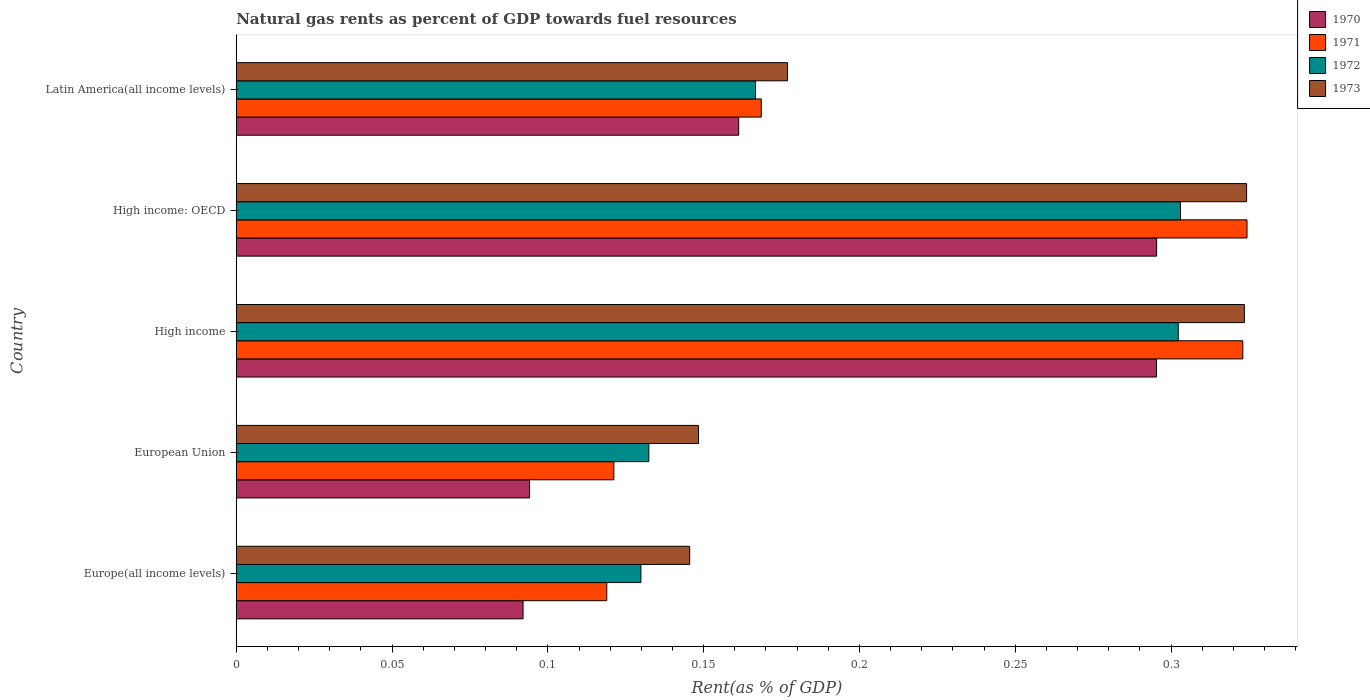How many groups of bars are there?
Offer a very short reply. 5. Are the number of bars per tick equal to the number of legend labels?
Give a very brief answer. Yes. How many bars are there on the 2nd tick from the bottom?
Give a very brief answer. 4. What is the matural gas rent in 1971 in High income: OECD?
Provide a succinct answer. 0.32. Across all countries, what is the maximum matural gas rent in 1973?
Give a very brief answer. 0.32. Across all countries, what is the minimum matural gas rent in 1970?
Your answer should be very brief. 0.09. In which country was the matural gas rent in 1973 maximum?
Provide a succinct answer. High income: OECD. In which country was the matural gas rent in 1970 minimum?
Offer a very short reply. Europe(all income levels). What is the total matural gas rent in 1970 in the graph?
Provide a succinct answer. 0.94. What is the difference between the matural gas rent in 1973 in High income and that in High income: OECD?
Provide a short and direct response. -0. What is the difference between the matural gas rent in 1970 in High income and the matural gas rent in 1973 in High income: OECD?
Ensure brevity in your answer.  -0.03. What is the average matural gas rent in 1970 per country?
Your response must be concise. 0.19. What is the difference between the matural gas rent in 1971 and matural gas rent in 1972 in Europe(all income levels)?
Offer a very short reply. -0.01. In how many countries, is the matural gas rent in 1973 greater than 0.02 %?
Your response must be concise. 5. What is the ratio of the matural gas rent in 1973 in Europe(all income levels) to that in European Union?
Your answer should be very brief. 0.98. Is the matural gas rent in 1972 in Europe(all income levels) less than that in Latin America(all income levels)?
Provide a short and direct response. Yes. What is the difference between the highest and the second highest matural gas rent in 1972?
Your response must be concise. 0. What is the difference between the highest and the lowest matural gas rent in 1972?
Provide a short and direct response. 0.17. Is the sum of the matural gas rent in 1970 in European Union and Latin America(all income levels) greater than the maximum matural gas rent in 1971 across all countries?
Ensure brevity in your answer.  No. Is it the case that in every country, the sum of the matural gas rent in 1971 and matural gas rent in 1970 is greater than the sum of matural gas rent in 1972 and matural gas rent in 1973?
Your response must be concise. No. What does the 3rd bar from the top in European Union represents?
Ensure brevity in your answer.  1971. Is it the case that in every country, the sum of the matural gas rent in 1973 and matural gas rent in 1970 is greater than the matural gas rent in 1972?
Ensure brevity in your answer.  Yes. How many bars are there?
Offer a very short reply. 20. Does the graph contain any zero values?
Offer a terse response. No. Does the graph contain grids?
Make the answer very short. No. How many legend labels are there?
Your answer should be very brief. 4. How are the legend labels stacked?
Offer a very short reply. Vertical. What is the title of the graph?
Provide a short and direct response. Natural gas rents as percent of GDP towards fuel resources. What is the label or title of the X-axis?
Your answer should be very brief. Rent(as % of GDP). What is the Rent(as % of GDP) in 1970 in Europe(all income levels)?
Make the answer very short. 0.09. What is the Rent(as % of GDP) in 1971 in Europe(all income levels)?
Provide a succinct answer. 0.12. What is the Rent(as % of GDP) of 1972 in Europe(all income levels)?
Provide a succinct answer. 0.13. What is the Rent(as % of GDP) in 1973 in Europe(all income levels)?
Your answer should be very brief. 0.15. What is the Rent(as % of GDP) in 1970 in European Union?
Provide a succinct answer. 0.09. What is the Rent(as % of GDP) of 1971 in European Union?
Provide a succinct answer. 0.12. What is the Rent(as % of GDP) of 1972 in European Union?
Your answer should be very brief. 0.13. What is the Rent(as % of GDP) in 1973 in European Union?
Your response must be concise. 0.15. What is the Rent(as % of GDP) of 1970 in High income?
Provide a short and direct response. 0.3. What is the Rent(as % of GDP) in 1971 in High income?
Ensure brevity in your answer.  0.32. What is the Rent(as % of GDP) in 1972 in High income?
Make the answer very short. 0.3. What is the Rent(as % of GDP) in 1973 in High income?
Keep it short and to the point. 0.32. What is the Rent(as % of GDP) in 1970 in High income: OECD?
Offer a terse response. 0.3. What is the Rent(as % of GDP) of 1971 in High income: OECD?
Keep it short and to the point. 0.32. What is the Rent(as % of GDP) of 1972 in High income: OECD?
Offer a terse response. 0.3. What is the Rent(as % of GDP) of 1973 in High income: OECD?
Your answer should be compact. 0.32. What is the Rent(as % of GDP) of 1970 in Latin America(all income levels)?
Offer a very short reply. 0.16. What is the Rent(as % of GDP) in 1971 in Latin America(all income levels)?
Provide a succinct answer. 0.17. What is the Rent(as % of GDP) of 1972 in Latin America(all income levels)?
Make the answer very short. 0.17. What is the Rent(as % of GDP) of 1973 in Latin America(all income levels)?
Ensure brevity in your answer.  0.18. Across all countries, what is the maximum Rent(as % of GDP) of 1970?
Give a very brief answer. 0.3. Across all countries, what is the maximum Rent(as % of GDP) in 1971?
Make the answer very short. 0.32. Across all countries, what is the maximum Rent(as % of GDP) of 1972?
Make the answer very short. 0.3. Across all countries, what is the maximum Rent(as % of GDP) in 1973?
Ensure brevity in your answer.  0.32. Across all countries, what is the minimum Rent(as % of GDP) in 1970?
Your answer should be very brief. 0.09. Across all countries, what is the minimum Rent(as % of GDP) in 1971?
Your answer should be compact. 0.12. Across all countries, what is the minimum Rent(as % of GDP) of 1972?
Give a very brief answer. 0.13. Across all countries, what is the minimum Rent(as % of GDP) of 1973?
Keep it short and to the point. 0.15. What is the total Rent(as % of GDP) in 1970 in the graph?
Keep it short and to the point. 0.94. What is the total Rent(as % of GDP) of 1971 in the graph?
Your answer should be compact. 1.06. What is the total Rent(as % of GDP) in 1972 in the graph?
Your answer should be compact. 1.03. What is the total Rent(as % of GDP) in 1973 in the graph?
Keep it short and to the point. 1.12. What is the difference between the Rent(as % of GDP) in 1970 in Europe(all income levels) and that in European Union?
Keep it short and to the point. -0. What is the difference between the Rent(as % of GDP) of 1971 in Europe(all income levels) and that in European Union?
Give a very brief answer. -0. What is the difference between the Rent(as % of GDP) of 1972 in Europe(all income levels) and that in European Union?
Your answer should be compact. -0. What is the difference between the Rent(as % of GDP) of 1973 in Europe(all income levels) and that in European Union?
Provide a succinct answer. -0. What is the difference between the Rent(as % of GDP) of 1970 in Europe(all income levels) and that in High income?
Provide a short and direct response. -0.2. What is the difference between the Rent(as % of GDP) in 1971 in Europe(all income levels) and that in High income?
Ensure brevity in your answer.  -0.2. What is the difference between the Rent(as % of GDP) of 1972 in Europe(all income levels) and that in High income?
Offer a terse response. -0.17. What is the difference between the Rent(as % of GDP) in 1973 in Europe(all income levels) and that in High income?
Provide a succinct answer. -0.18. What is the difference between the Rent(as % of GDP) in 1970 in Europe(all income levels) and that in High income: OECD?
Make the answer very short. -0.2. What is the difference between the Rent(as % of GDP) in 1971 in Europe(all income levels) and that in High income: OECD?
Give a very brief answer. -0.21. What is the difference between the Rent(as % of GDP) in 1972 in Europe(all income levels) and that in High income: OECD?
Provide a short and direct response. -0.17. What is the difference between the Rent(as % of GDP) in 1973 in Europe(all income levels) and that in High income: OECD?
Ensure brevity in your answer.  -0.18. What is the difference between the Rent(as % of GDP) in 1970 in Europe(all income levels) and that in Latin America(all income levels)?
Your answer should be very brief. -0.07. What is the difference between the Rent(as % of GDP) of 1971 in Europe(all income levels) and that in Latin America(all income levels)?
Provide a succinct answer. -0.05. What is the difference between the Rent(as % of GDP) in 1972 in Europe(all income levels) and that in Latin America(all income levels)?
Make the answer very short. -0.04. What is the difference between the Rent(as % of GDP) of 1973 in Europe(all income levels) and that in Latin America(all income levels)?
Provide a short and direct response. -0.03. What is the difference between the Rent(as % of GDP) of 1970 in European Union and that in High income?
Provide a succinct answer. -0.2. What is the difference between the Rent(as % of GDP) in 1971 in European Union and that in High income?
Ensure brevity in your answer.  -0.2. What is the difference between the Rent(as % of GDP) in 1972 in European Union and that in High income?
Offer a terse response. -0.17. What is the difference between the Rent(as % of GDP) in 1973 in European Union and that in High income?
Keep it short and to the point. -0.18. What is the difference between the Rent(as % of GDP) in 1970 in European Union and that in High income: OECD?
Give a very brief answer. -0.2. What is the difference between the Rent(as % of GDP) of 1971 in European Union and that in High income: OECD?
Your answer should be very brief. -0.2. What is the difference between the Rent(as % of GDP) of 1972 in European Union and that in High income: OECD?
Offer a terse response. -0.17. What is the difference between the Rent(as % of GDP) of 1973 in European Union and that in High income: OECD?
Your response must be concise. -0.18. What is the difference between the Rent(as % of GDP) in 1970 in European Union and that in Latin America(all income levels)?
Your answer should be compact. -0.07. What is the difference between the Rent(as % of GDP) of 1971 in European Union and that in Latin America(all income levels)?
Your answer should be very brief. -0.05. What is the difference between the Rent(as % of GDP) in 1972 in European Union and that in Latin America(all income levels)?
Offer a terse response. -0.03. What is the difference between the Rent(as % of GDP) in 1973 in European Union and that in Latin America(all income levels)?
Keep it short and to the point. -0.03. What is the difference between the Rent(as % of GDP) in 1970 in High income and that in High income: OECD?
Your answer should be compact. -0. What is the difference between the Rent(as % of GDP) of 1971 in High income and that in High income: OECD?
Your answer should be very brief. -0. What is the difference between the Rent(as % of GDP) in 1972 in High income and that in High income: OECD?
Provide a short and direct response. -0. What is the difference between the Rent(as % of GDP) in 1973 in High income and that in High income: OECD?
Provide a succinct answer. -0. What is the difference between the Rent(as % of GDP) of 1970 in High income and that in Latin America(all income levels)?
Your response must be concise. 0.13. What is the difference between the Rent(as % of GDP) in 1971 in High income and that in Latin America(all income levels)?
Give a very brief answer. 0.15. What is the difference between the Rent(as % of GDP) of 1972 in High income and that in Latin America(all income levels)?
Offer a very short reply. 0.14. What is the difference between the Rent(as % of GDP) of 1973 in High income and that in Latin America(all income levels)?
Your answer should be compact. 0.15. What is the difference between the Rent(as % of GDP) of 1970 in High income: OECD and that in Latin America(all income levels)?
Provide a succinct answer. 0.13. What is the difference between the Rent(as % of GDP) in 1971 in High income: OECD and that in Latin America(all income levels)?
Provide a short and direct response. 0.16. What is the difference between the Rent(as % of GDP) in 1972 in High income: OECD and that in Latin America(all income levels)?
Your answer should be very brief. 0.14. What is the difference between the Rent(as % of GDP) of 1973 in High income: OECD and that in Latin America(all income levels)?
Your response must be concise. 0.15. What is the difference between the Rent(as % of GDP) of 1970 in Europe(all income levels) and the Rent(as % of GDP) of 1971 in European Union?
Provide a short and direct response. -0.03. What is the difference between the Rent(as % of GDP) in 1970 in Europe(all income levels) and the Rent(as % of GDP) in 1972 in European Union?
Provide a short and direct response. -0.04. What is the difference between the Rent(as % of GDP) in 1970 in Europe(all income levels) and the Rent(as % of GDP) in 1973 in European Union?
Your answer should be very brief. -0.06. What is the difference between the Rent(as % of GDP) in 1971 in Europe(all income levels) and the Rent(as % of GDP) in 1972 in European Union?
Provide a succinct answer. -0.01. What is the difference between the Rent(as % of GDP) in 1971 in Europe(all income levels) and the Rent(as % of GDP) in 1973 in European Union?
Provide a succinct answer. -0.03. What is the difference between the Rent(as % of GDP) of 1972 in Europe(all income levels) and the Rent(as % of GDP) of 1973 in European Union?
Provide a succinct answer. -0.02. What is the difference between the Rent(as % of GDP) in 1970 in Europe(all income levels) and the Rent(as % of GDP) in 1971 in High income?
Offer a very short reply. -0.23. What is the difference between the Rent(as % of GDP) of 1970 in Europe(all income levels) and the Rent(as % of GDP) of 1972 in High income?
Your response must be concise. -0.21. What is the difference between the Rent(as % of GDP) in 1970 in Europe(all income levels) and the Rent(as % of GDP) in 1973 in High income?
Your response must be concise. -0.23. What is the difference between the Rent(as % of GDP) of 1971 in Europe(all income levels) and the Rent(as % of GDP) of 1972 in High income?
Your answer should be very brief. -0.18. What is the difference between the Rent(as % of GDP) of 1971 in Europe(all income levels) and the Rent(as % of GDP) of 1973 in High income?
Your answer should be very brief. -0.2. What is the difference between the Rent(as % of GDP) of 1972 in Europe(all income levels) and the Rent(as % of GDP) of 1973 in High income?
Your answer should be very brief. -0.19. What is the difference between the Rent(as % of GDP) of 1970 in Europe(all income levels) and the Rent(as % of GDP) of 1971 in High income: OECD?
Give a very brief answer. -0.23. What is the difference between the Rent(as % of GDP) of 1970 in Europe(all income levels) and the Rent(as % of GDP) of 1972 in High income: OECD?
Make the answer very short. -0.21. What is the difference between the Rent(as % of GDP) of 1970 in Europe(all income levels) and the Rent(as % of GDP) of 1973 in High income: OECD?
Provide a succinct answer. -0.23. What is the difference between the Rent(as % of GDP) in 1971 in Europe(all income levels) and the Rent(as % of GDP) in 1972 in High income: OECD?
Your answer should be compact. -0.18. What is the difference between the Rent(as % of GDP) of 1971 in Europe(all income levels) and the Rent(as % of GDP) of 1973 in High income: OECD?
Make the answer very short. -0.21. What is the difference between the Rent(as % of GDP) of 1972 in Europe(all income levels) and the Rent(as % of GDP) of 1973 in High income: OECD?
Your response must be concise. -0.19. What is the difference between the Rent(as % of GDP) of 1970 in Europe(all income levels) and the Rent(as % of GDP) of 1971 in Latin America(all income levels)?
Offer a very short reply. -0.08. What is the difference between the Rent(as % of GDP) in 1970 in Europe(all income levels) and the Rent(as % of GDP) in 1972 in Latin America(all income levels)?
Your response must be concise. -0.07. What is the difference between the Rent(as % of GDP) of 1970 in Europe(all income levels) and the Rent(as % of GDP) of 1973 in Latin America(all income levels)?
Your answer should be compact. -0.08. What is the difference between the Rent(as % of GDP) of 1971 in Europe(all income levels) and the Rent(as % of GDP) of 1972 in Latin America(all income levels)?
Provide a short and direct response. -0.05. What is the difference between the Rent(as % of GDP) in 1971 in Europe(all income levels) and the Rent(as % of GDP) in 1973 in Latin America(all income levels)?
Ensure brevity in your answer.  -0.06. What is the difference between the Rent(as % of GDP) of 1972 in Europe(all income levels) and the Rent(as % of GDP) of 1973 in Latin America(all income levels)?
Give a very brief answer. -0.05. What is the difference between the Rent(as % of GDP) of 1970 in European Union and the Rent(as % of GDP) of 1971 in High income?
Your answer should be very brief. -0.23. What is the difference between the Rent(as % of GDP) in 1970 in European Union and the Rent(as % of GDP) in 1972 in High income?
Provide a short and direct response. -0.21. What is the difference between the Rent(as % of GDP) in 1970 in European Union and the Rent(as % of GDP) in 1973 in High income?
Offer a very short reply. -0.23. What is the difference between the Rent(as % of GDP) in 1971 in European Union and the Rent(as % of GDP) in 1972 in High income?
Make the answer very short. -0.18. What is the difference between the Rent(as % of GDP) of 1971 in European Union and the Rent(as % of GDP) of 1973 in High income?
Your response must be concise. -0.2. What is the difference between the Rent(as % of GDP) of 1972 in European Union and the Rent(as % of GDP) of 1973 in High income?
Your response must be concise. -0.19. What is the difference between the Rent(as % of GDP) in 1970 in European Union and the Rent(as % of GDP) in 1971 in High income: OECD?
Your answer should be very brief. -0.23. What is the difference between the Rent(as % of GDP) of 1970 in European Union and the Rent(as % of GDP) of 1972 in High income: OECD?
Your response must be concise. -0.21. What is the difference between the Rent(as % of GDP) of 1970 in European Union and the Rent(as % of GDP) of 1973 in High income: OECD?
Your answer should be very brief. -0.23. What is the difference between the Rent(as % of GDP) of 1971 in European Union and the Rent(as % of GDP) of 1972 in High income: OECD?
Your response must be concise. -0.18. What is the difference between the Rent(as % of GDP) in 1971 in European Union and the Rent(as % of GDP) in 1973 in High income: OECD?
Provide a short and direct response. -0.2. What is the difference between the Rent(as % of GDP) in 1972 in European Union and the Rent(as % of GDP) in 1973 in High income: OECD?
Make the answer very short. -0.19. What is the difference between the Rent(as % of GDP) of 1970 in European Union and the Rent(as % of GDP) of 1971 in Latin America(all income levels)?
Your answer should be very brief. -0.07. What is the difference between the Rent(as % of GDP) in 1970 in European Union and the Rent(as % of GDP) in 1972 in Latin America(all income levels)?
Your response must be concise. -0.07. What is the difference between the Rent(as % of GDP) of 1970 in European Union and the Rent(as % of GDP) of 1973 in Latin America(all income levels)?
Provide a short and direct response. -0.08. What is the difference between the Rent(as % of GDP) of 1971 in European Union and the Rent(as % of GDP) of 1972 in Latin America(all income levels)?
Offer a very short reply. -0.05. What is the difference between the Rent(as % of GDP) of 1971 in European Union and the Rent(as % of GDP) of 1973 in Latin America(all income levels)?
Keep it short and to the point. -0.06. What is the difference between the Rent(as % of GDP) of 1972 in European Union and the Rent(as % of GDP) of 1973 in Latin America(all income levels)?
Offer a terse response. -0.04. What is the difference between the Rent(as % of GDP) of 1970 in High income and the Rent(as % of GDP) of 1971 in High income: OECD?
Provide a short and direct response. -0.03. What is the difference between the Rent(as % of GDP) in 1970 in High income and the Rent(as % of GDP) in 1972 in High income: OECD?
Offer a terse response. -0.01. What is the difference between the Rent(as % of GDP) of 1970 in High income and the Rent(as % of GDP) of 1973 in High income: OECD?
Your answer should be compact. -0.03. What is the difference between the Rent(as % of GDP) of 1971 in High income and the Rent(as % of GDP) of 1973 in High income: OECD?
Your response must be concise. -0. What is the difference between the Rent(as % of GDP) in 1972 in High income and the Rent(as % of GDP) in 1973 in High income: OECD?
Make the answer very short. -0.02. What is the difference between the Rent(as % of GDP) in 1970 in High income and the Rent(as % of GDP) in 1971 in Latin America(all income levels)?
Your answer should be compact. 0.13. What is the difference between the Rent(as % of GDP) of 1970 in High income and the Rent(as % of GDP) of 1972 in Latin America(all income levels)?
Your answer should be very brief. 0.13. What is the difference between the Rent(as % of GDP) in 1970 in High income and the Rent(as % of GDP) in 1973 in Latin America(all income levels)?
Provide a short and direct response. 0.12. What is the difference between the Rent(as % of GDP) in 1971 in High income and the Rent(as % of GDP) in 1972 in Latin America(all income levels)?
Provide a succinct answer. 0.16. What is the difference between the Rent(as % of GDP) in 1971 in High income and the Rent(as % of GDP) in 1973 in Latin America(all income levels)?
Your response must be concise. 0.15. What is the difference between the Rent(as % of GDP) in 1972 in High income and the Rent(as % of GDP) in 1973 in Latin America(all income levels)?
Your answer should be compact. 0.13. What is the difference between the Rent(as % of GDP) of 1970 in High income: OECD and the Rent(as % of GDP) of 1971 in Latin America(all income levels)?
Your answer should be compact. 0.13. What is the difference between the Rent(as % of GDP) in 1970 in High income: OECD and the Rent(as % of GDP) in 1972 in Latin America(all income levels)?
Your answer should be compact. 0.13. What is the difference between the Rent(as % of GDP) in 1970 in High income: OECD and the Rent(as % of GDP) in 1973 in Latin America(all income levels)?
Provide a succinct answer. 0.12. What is the difference between the Rent(as % of GDP) in 1971 in High income: OECD and the Rent(as % of GDP) in 1972 in Latin America(all income levels)?
Give a very brief answer. 0.16. What is the difference between the Rent(as % of GDP) in 1971 in High income: OECD and the Rent(as % of GDP) in 1973 in Latin America(all income levels)?
Your answer should be compact. 0.15. What is the difference between the Rent(as % of GDP) of 1972 in High income: OECD and the Rent(as % of GDP) of 1973 in Latin America(all income levels)?
Your response must be concise. 0.13. What is the average Rent(as % of GDP) in 1970 per country?
Provide a succinct answer. 0.19. What is the average Rent(as % of GDP) in 1971 per country?
Offer a terse response. 0.21. What is the average Rent(as % of GDP) in 1972 per country?
Offer a very short reply. 0.21. What is the average Rent(as % of GDP) in 1973 per country?
Provide a short and direct response. 0.22. What is the difference between the Rent(as % of GDP) of 1970 and Rent(as % of GDP) of 1971 in Europe(all income levels)?
Ensure brevity in your answer.  -0.03. What is the difference between the Rent(as % of GDP) in 1970 and Rent(as % of GDP) in 1972 in Europe(all income levels)?
Your answer should be very brief. -0.04. What is the difference between the Rent(as % of GDP) of 1970 and Rent(as % of GDP) of 1973 in Europe(all income levels)?
Offer a terse response. -0.05. What is the difference between the Rent(as % of GDP) in 1971 and Rent(as % of GDP) in 1972 in Europe(all income levels)?
Give a very brief answer. -0.01. What is the difference between the Rent(as % of GDP) in 1971 and Rent(as % of GDP) in 1973 in Europe(all income levels)?
Keep it short and to the point. -0.03. What is the difference between the Rent(as % of GDP) of 1972 and Rent(as % of GDP) of 1973 in Europe(all income levels)?
Make the answer very short. -0.02. What is the difference between the Rent(as % of GDP) in 1970 and Rent(as % of GDP) in 1971 in European Union?
Ensure brevity in your answer.  -0.03. What is the difference between the Rent(as % of GDP) in 1970 and Rent(as % of GDP) in 1972 in European Union?
Your answer should be very brief. -0.04. What is the difference between the Rent(as % of GDP) in 1970 and Rent(as % of GDP) in 1973 in European Union?
Offer a terse response. -0.05. What is the difference between the Rent(as % of GDP) of 1971 and Rent(as % of GDP) of 1972 in European Union?
Provide a short and direct response. -0.01. What is the difference between the Rent(as % of GDP) in 1971 and Rent(as % of GDP) in 1973 in European Union?
Keep it short and to the point. -0.03. What is the difference between the Rent(as % of GDP) in 1972 and Rent(as % of GDP) in 1973 in European Union?
Provide a short and direct response. -0.02. What is the difference between the Rent(as % of GDP) in 1970 and Rent(as % of GDP) in 1971 in High income?
Offer a very short reply. -0.03. What is the difference between the Rent(as % of GDP) in 1970 and Rent(as % of GDP) in 1972 in High income?
Provide a succinct answer. -0.01. What is the difference between the Rent(as % of GDP) in 1970 and Rent(as % of GDP) in 1973 in High income?
Your answer should be very brief. -0.03. What is the difference between the Rent(as % of GDP) in 1971 and Rent(as % of GDP) in 1972 in High income?
Your response must be concise. 0.02. What is the difference between the Rent(as % of GDP) of 1971 and Rent(as % of GDP) of 1973 in High income?
Provide a succinct answer. -0. What is the difference between the Rent(as % of GDP) of 1972 and Rent(as % of GDP) of 1973 in High income?
Keep it short and to the point. -0.02. What is the difference between the Rent(as % of GDP) of 1970 and Rent(as % of GDP) of 1971 in High income: OECD?
Keep it short and to the point. -0.03. What is the difference between the Rent(as % of GDP) in 1970 and Rent(as % of GDP) in 1972 in High income: OECD?
Your response must be concise. -0.01. What is the difference between the Rent(as % of GDP) in 1970 and Rent(as % of GDP) in 1973 in High income: OECD?
Your answer should be compact. -0.03. What is the difference between the Rent(as % of GDP) in 1971 and Rent(as % of GDP) in 1972 in High income: OECD?
Offer a terse response. 0.02. What is the difference between the Rent(as % of GDP) in 1971 and Rent(as % of GDP) in 1973 in High income: OECD?
Your answer should be very brief. 0. What is the difference between the Rent(as % of GDP) of 1972 and Rent(as % of GDP) of 1973 in High income: OECD?
Make the answer very short. -0.02. What is the difference between the Rent(as % of GDP) of 1970 and Rent(as % of GDP) of 1971 in Latin America(all income levels)?
Your answer should be very brief. -0.01. What is the difference between the Rent(as % of GDP) in 1970 and Rent(as % of GDP) in 1972 in Latin America(all income levels)?
Provide a succinct answer. -0.01. What is the difference between the Rent(as % of GDP) of 1970 and Rent(as % of GDP) of 1973 in Latin America(all income levels)?
Offer a very short reply. -0.02. What is the difference between the Rent(as % of GDP) of 1971 and Rent(as % of GDP) of 1972 in Latin America(all income levels)?
Keep it short and to the point. 0. What is the difference between the Rent(as % of GDP) in 1971 and Rent(as % of GDP) in 1973 in Latin America(all income levels)?
Keep it short and to the point. -0.01. What is the difference between the Rent(as % of GDP) in 1972 and Rent(as % of GDP) in 1973 in Latin America(all income levels)?
Provide a short and direct response. -0.01. What is the ratio of the Rent(as % of GDP) of 1970 in Europe(all income levels) to that in European Union?
Your answer should be very brief. 0.98. What is the ratio of the Rent(as % of GDP) in 1971 in Europe(all income levels) to that in European Union?
Your response must be concise. 0.98. What is the ratio of the Rent(as % of GDP) of 1972 in Europe(all income levels) to that in European Union?
Make the answer very short. 0.98. What is the ratio of the Rent(as % of GDP) in 1973 in Europe(all income levels) to that in European Union?
Give a very brief answer. 0.98. What is the ratio of the Rent(as % of GDP) of 1970 in Europe(all income levels) to that in High income?
Keep it short and to the point. 0.31. What is the ratio of the Rent(as % of GDP) in 1971 in Europe(all income levels) to that in High income?
Ensure brevity in your answer.  0.37. What is the ratio of the Rent(as % of GDP) in 1972 in Europe(all income levels) to that in High income?
Keep it short and to the point. 0.43. What is the ratio of the Rent(as % of GDP) of 1973 in Europe(all income levels) to that in High income?
Give a very brief answer. 0.45. What is the ratio of the Rent(as % of GDP) of 1970 in Europe(all income levels) to that in High income: OECD?
Offer a terse response. 0.31. What is the ratio of the Rent(as % of GDP) in 1971 in Europe(all income levels) to that in High income: OECD?
Ensure brevity in your answer.  0.37. What is the ratio of the Rent(as % of GDP) in 1972 in Europe(all income levels) to that in High income: OECD?
Provide a succinct answer. 0.43. What is the ratio of the Rent(as % of GDP) of 1973 in Europe(all income levels) to that in High income: OECD?
Provide a succinct answer. 0.45. What is the ratio of the Rent(as % of GDP) in 1970 in Europe(all income levels) to that in Latin America(all income levels)?
Your answer should be very brief. 0.57. What is the ratio of the Rent(as % of GDP) of 1971 in Europe(all income levels) to that in Latin America(all income levels)?
Keep it short and to the point. 0.71. What is the ratio of the Rent(as % of GDP) of 1972 in Europe(all income levels) to that in Latin America(all income levels)?
Offer a terse response. 0.78. What is the ratio of the Rent(as % of GDP) in 1973 in Europe(all income levels) to that in Latin America(all income levels)?
Give a very brief answer. 0.82. What is the ratio of the Rent(as % of GDP) of 1970 in European Union to that in High income?
Make the answer very short. 0.32. What is the ratio of the Rent(as % of GDP) of 1971 in European Union to that in High income?
Your answer should be compact. 0.38. What is the ratio of the Rent(as % of GDP) in 1972 in European Union to that in High income?
Give a very brief answer. 0.44. What is the ratio of the Rent(as % of GDP) of 1973 in European Union to that in High income?
Provide a short and direct response. 0.46. What is the ratio of the Rent(as % of GDP) in 1970 in European Union to that in High income: OECD?
Provide a succinct answer. 0.32. What is the ratio of the Rent(as % of GDP) of 1971 in European Union to that in High income: OECD?
Your response must be concise. 0.37. What is the ratio of the Rent(as % of GDP) in 1972 in European Union to that in High income: OECD?
Offer a terse response. 0.44. What is the ratio of the Rent(as % of GDP) in 1973 in European Union to that in High income: OECD?
Your response must be concise. 0.46. What is the ratio of the Rent(as % of GDP) of 1970 in European Union to that in Latin America(all income levels)?
Provide a succinct answer. 0.58. What is the ratio of the Rent(as % of GDP) of 1971 in European Union to that in Latin America(all income levels)?
Keep it short and to the point. 0.72. What is the ratio of the Rent(as % of GDP) of 1972 in European Union to that in Latin America(all income levels)?
Keep it short and to the point. 0.79. What is the ratio of the Rent(as % of GDP) in 1973 in European Union to that in Latin America(all income levels)?
Provide a short and direct response. 0.84. What is the ratio of the Rent(as % of GDP) in 1970 in High income to that in High income: OECD?
Your answer should be compact. 1. What is the ratio of the Rent(as % of GDP) in 1971 in High income to that in High income: OECD?
Give a very brief answer. 1. What is the ratio of the Rent(as % of GDP) in 1972 in High income to that in High income: OECD?
Ensure brevity in your answer.  1. What is the ratio of the Rent(as % of GDP) in 1973 in High income to that in High income: OECD?
Make the answer very short. 1. What is the ratio of the Rent(as % of GDP) of 1970 in High income to that in Latin America(all income levels)?
Offer a very short reply. 1.83. What is the ratio of the Rent(as % of GDP) of 1971 in High income to that in Latin America(all income levels)?
Provide a succinct answer. 1.92. What is the ratio of the Rent(as % of GDP) of 1972 in High income to that in Latin America(all income levels)?
Provide a short and direct response. 1.81. What is the ratio of the Rent(as % of GDP) of 1973 in High income to that in Latin America(all income levels)?
Ensure brevity in your answer.  1.83. What is the ratio of the Rent(as % of GDP) of 1970 in High income: OECD to that in Latin America(all income levels)?
Provide a short and direct response. 1.83. What is the ratio of the Rent(as % of GDP) of 1971 in High income: OECD to that in Latin America(all income levels)?
Offer a very short reply. 1.93. What is the ratio of the Rent(as % of GDP) in 1972 in High income: OECD to that in Latin America(all income levels)?
Offer a terse response. 1.82. What is the ratio of the Rent(as % of GDP) in 1973 in High income: OECD to that in Latin America(all income levels)?
Ensure brevity in your answer.  1.83. What is the difference between the highest and the second highest Rent(as % of GDP) of 1971?
Your answer should be very brief. 0. What is the difference between the highest and the second highest Rent(as % of GDP) in 1972?
Your response must be concise. 0. What is the difference between the highest and the second highest Rent(as % of GDP) in 1973?
Your answer should be very brief. 0. What is the difference between the highest and the lowest Rent(as % of GDP) in 1970?
Your response must be concise. 0.2. What is the difference between the highest and the lowest Rent(as % of GDP) of 1971?
Your answer should be compact. 0.21. What is the difference between the highest and the lowest Rent(as % of GDP) of 1972?
Your response must be concise. 0.17. What is the difference between the highest and the lowest Rent(as % of GDP) in 1973?
Your answer should be very brief. 0.18. 